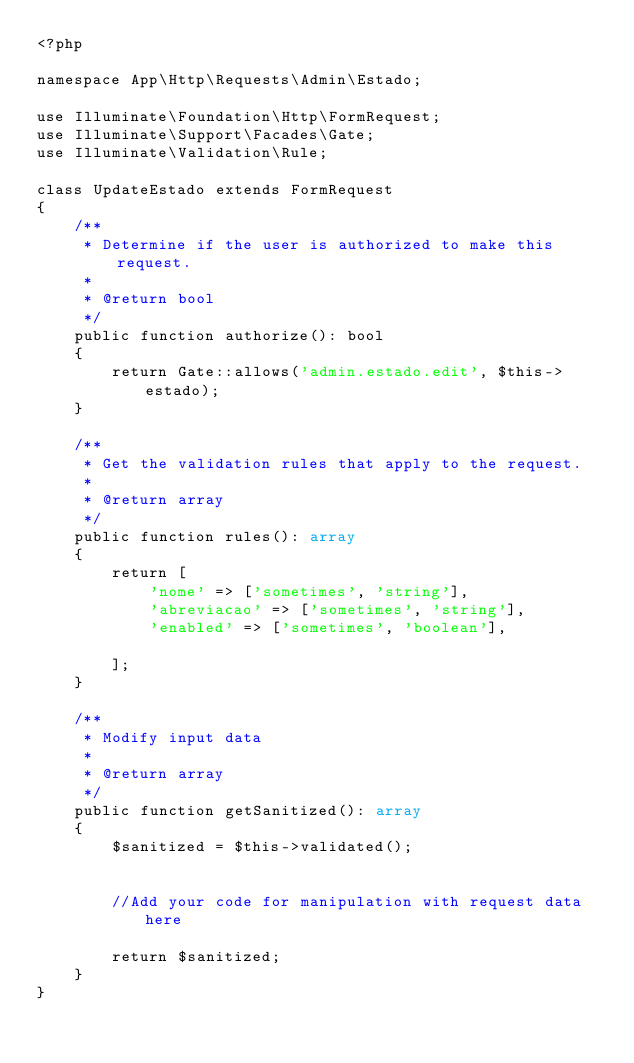Convert code to text. <code><loc_0><loc_0><loc_500><loc_500><_PHP_><?php

namespace App\Http\Requests\Admin\Estado;

use Illuminate\Foundation\Http\FormRequest;
use Illuminate\Support\Facades\Gate;
use Illuminate\Validation\Rule;

class UpdateEstado extends FormRequest
{
    /**
     * Determine if the user is authorized to make this request.
     *
     * @return bool
     */
    public function authorize(): bool
    {
        return Gate::allows('admin.estado.edit', $this->estado);
    }

    /**
     * Get the validation rules that apply to the request.
     *
     * @return array
     */
    public function rules(): array
    {
        return [
            'nome' => ['sometimes', 'string'],
            'abreviacao' => ['sometimes', 'string'],
            'enabled' => ['sometimes', 'boolean'],

        ];
    }

    /**
     * Modify input data
     *
     * @return array
     */
    public function getSanitized(): array
    {
        $sanitized = $this->validated();


        //Add your code for manipulation with request data here

        return $sanitized;
    }
}
</code> 